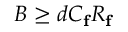Convert formula to latex. <formula><loc_0><loc_0><loc_500><loc_500>B \geq d C _ { f } R _ { f }</formula> 